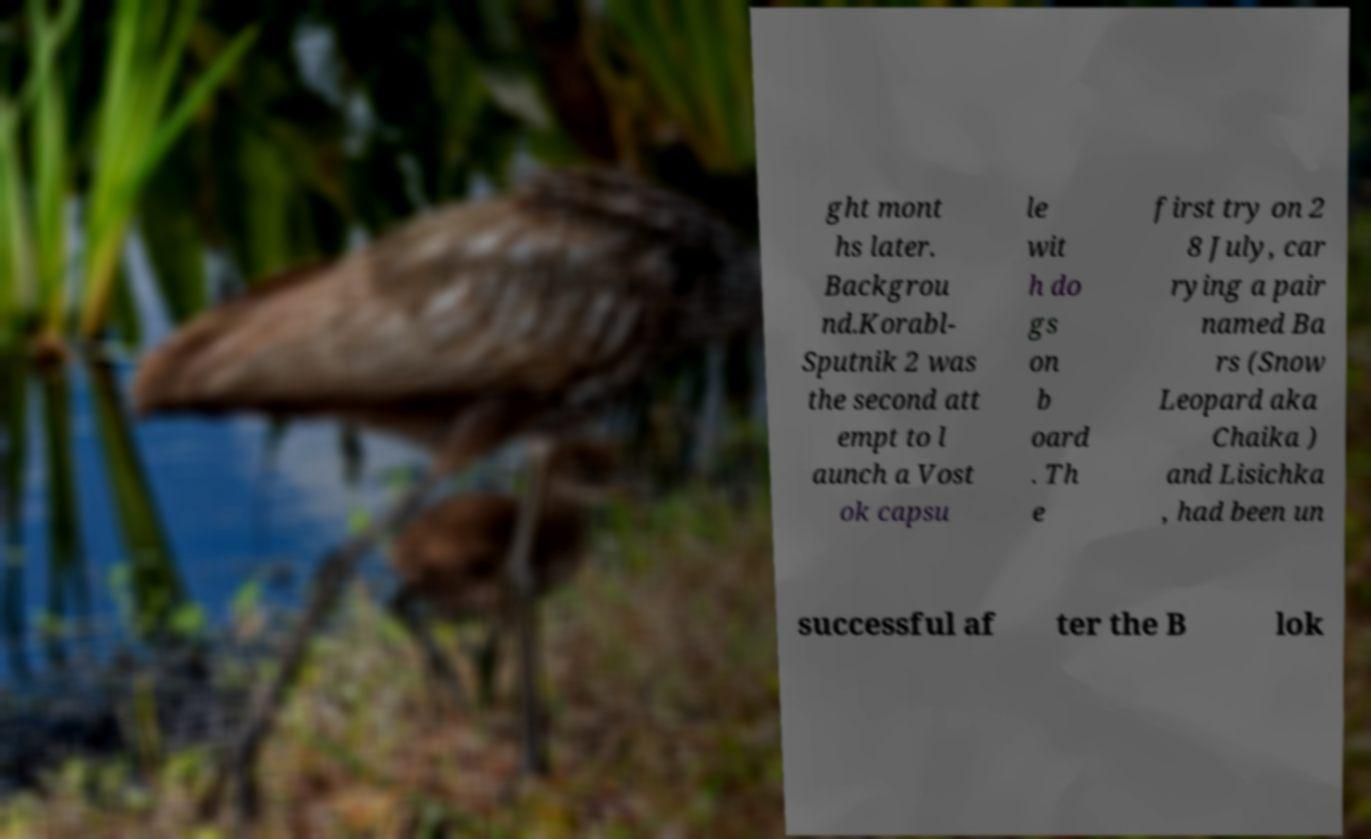Please identify and transcribe the text found in this image. ght mont hs later. Backgrou nd.Korabl- Sputnik 2 was the second att empt to l aunch a Vost ok capsu le wit h do gs on b oard . Th e first try on 2 8 July, car rying a pair named Ba rs (Snow Leopard aka Chaika ) and Lisichka , had been un successful af ter the B lok 